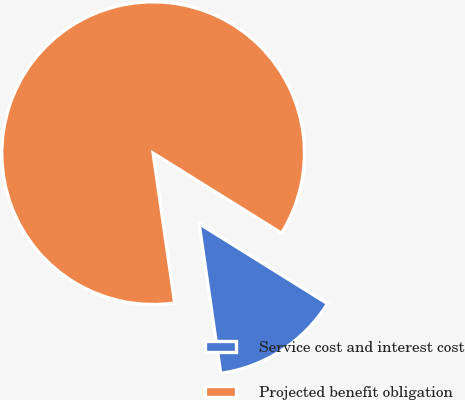Convert chart. <chart><loc_0><loc_0><loc_500><loc_500><pie_chart><fcel>Service cost and interest cost<fcel>Projected benefit obligation<nl><fcel>13.85%<fcel>86.15%<nl></chart> 